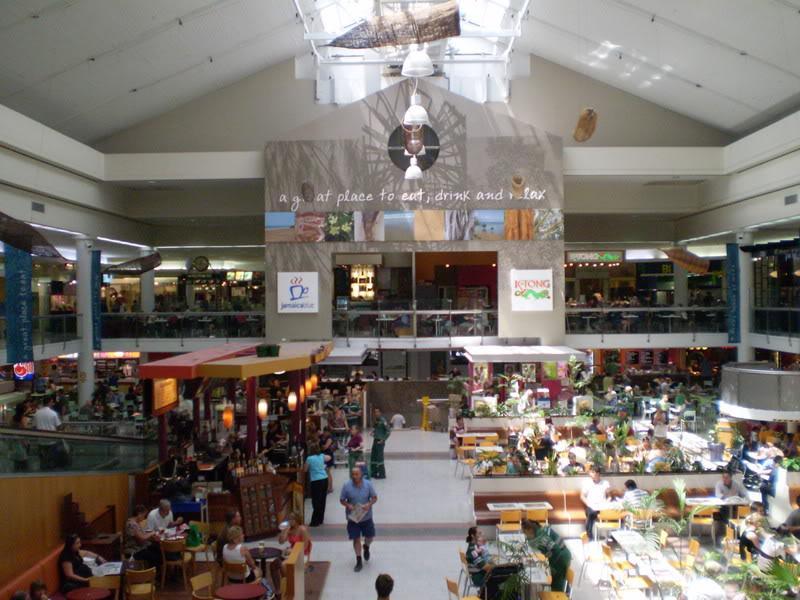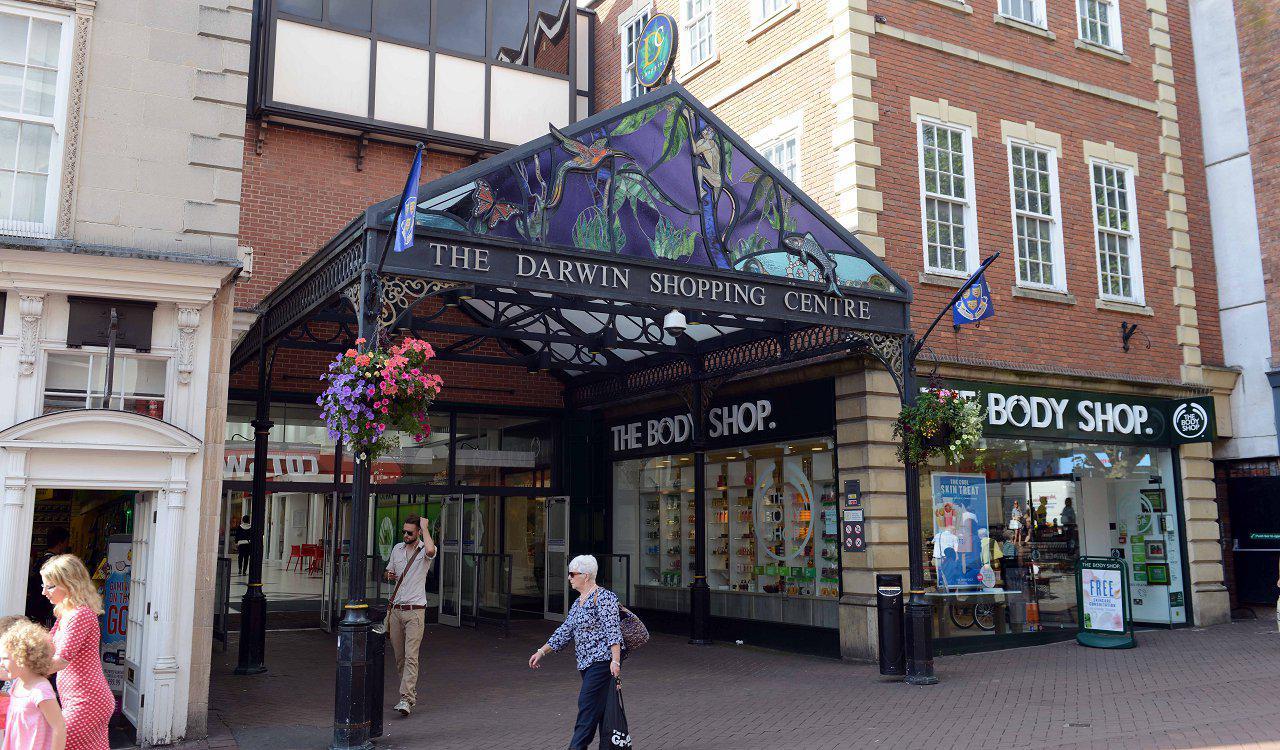The first image is the image on the left, the second image is the image on the right. For the images displayed, is the sentence "In the image on the left, at least 8 people are sitting at tables in the food court." factually correct? Answer yes or no. Yes. The first image is the image on the left, the second image is the image on the right. Considering the images on both sides, is "At least one of the images includes a tree." valid? Answer yes or no. No. 